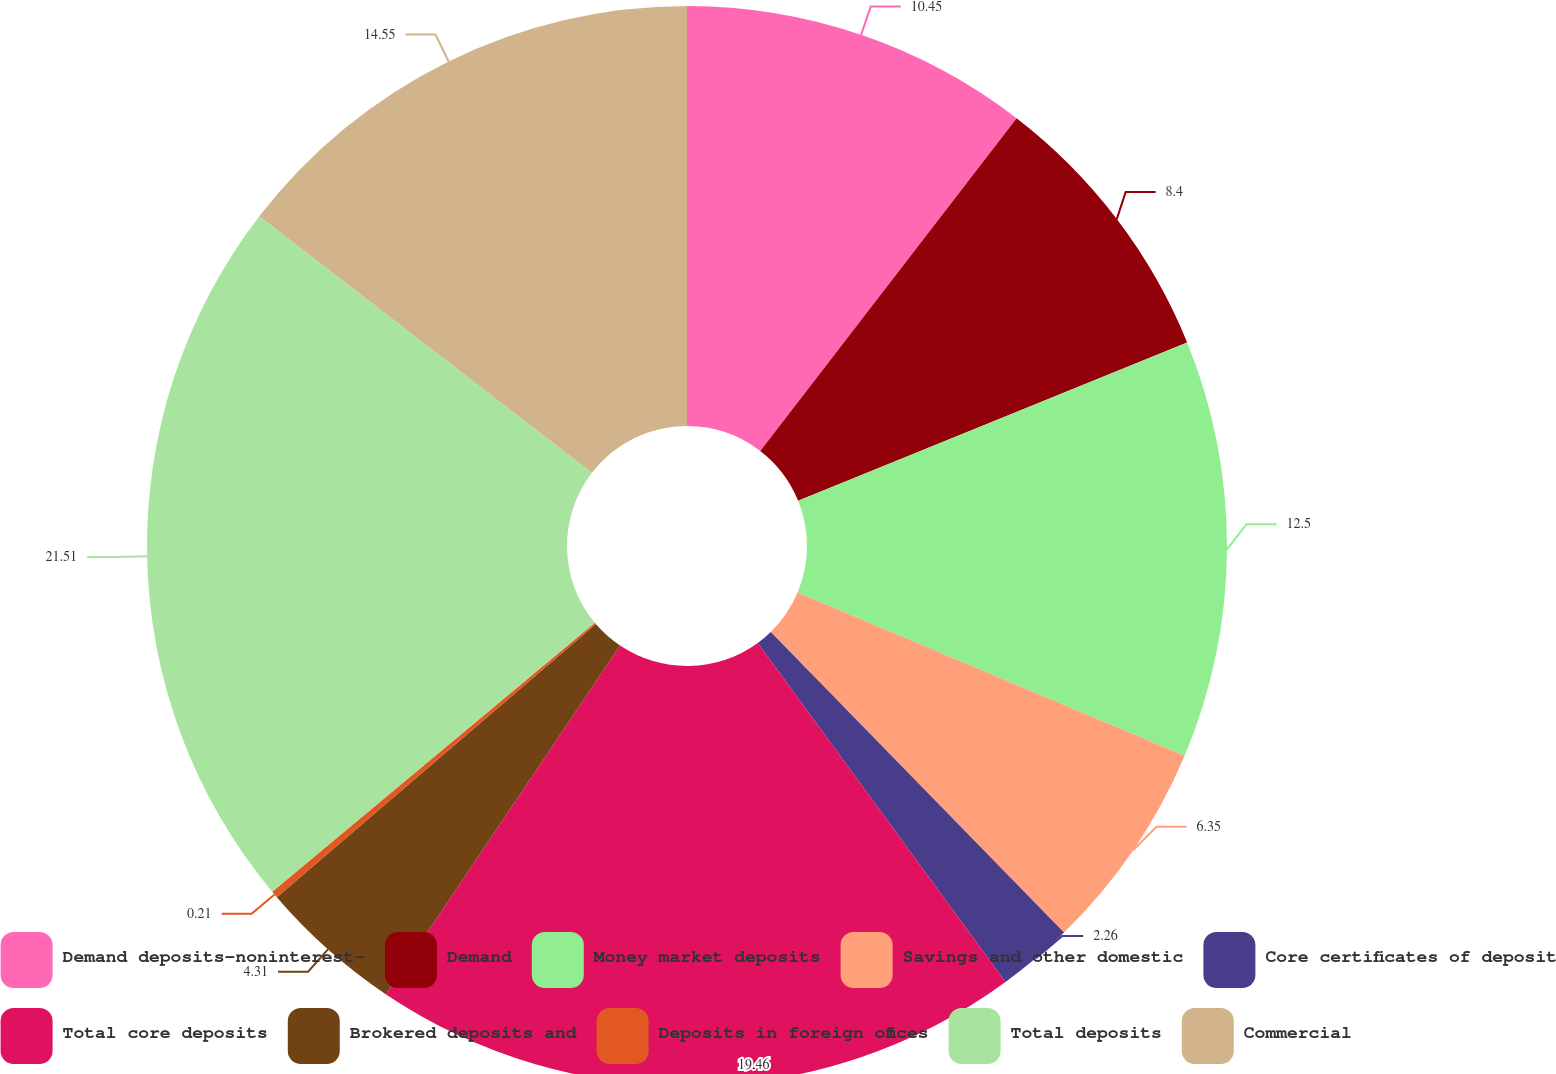Convert chart to OTSL. <chart><loc_0><loc_0><loc_500><loc_500><pie_chart><fcel>Demand deposits-noninterest-<fcel>Demand<fcel>Money market deposits<fcel>Savings and other domestic<fcel>Core certificates of deposit<fcel>Total core deposits<fcel>Brokered deposits and<fcel>Deposits in foreign offices<fcel>Total deposits<fcel>Commercial<nl><fcel>10.45%<fcel>8.4%<fcel>12.5%<fcel>6.35%<fcel>2.26%<fcel>19.46%<fcel>4.31%<fcel>0.21%<fcel>21.51%<fcel>14.55%<nl></chart> 